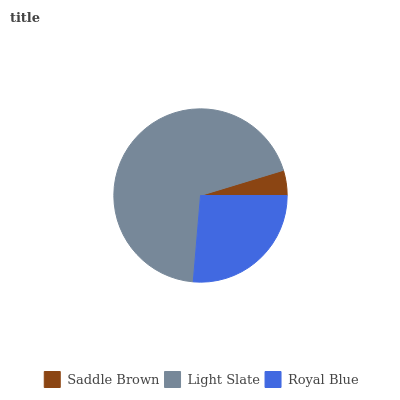Is Saddle Brown the minimum?
Answer yes or no. Yes. Is Light Slate the maximum?
Answer yes or no. Yes. Is Royal Blue the minimum?
Answer yes or no. No. Is Royal Blue the maximum?
Answer yes or no. No. Is Light Slate greater than Royal Blue?
Answer yes or no. Yes. Is Royal Blue less than Light Slate?
Answer yes or no. Yes. Is Royal Blue greater than Light Slate?
Answer yes or no. No. Is Light Slate less than Royal Blue?
Answer yes or no. No. Is Royal Blue the high median?
Answer yes or no. Yes. Is Royal Blue the low median?
Answer yes or no. Yes. Is Light Slate the high median?
Answer yes or no. No. Is Saddle Brown the low median?
Answer yes or no. No. 